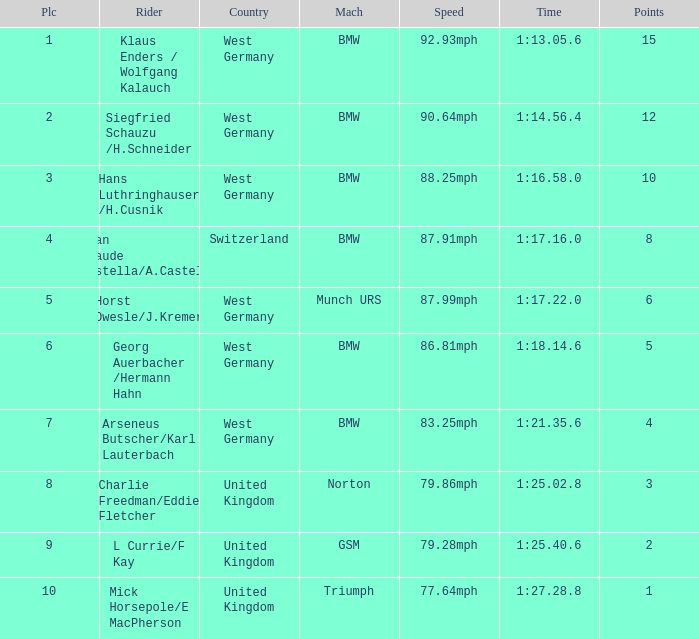Which places have points larger than 10? None. 